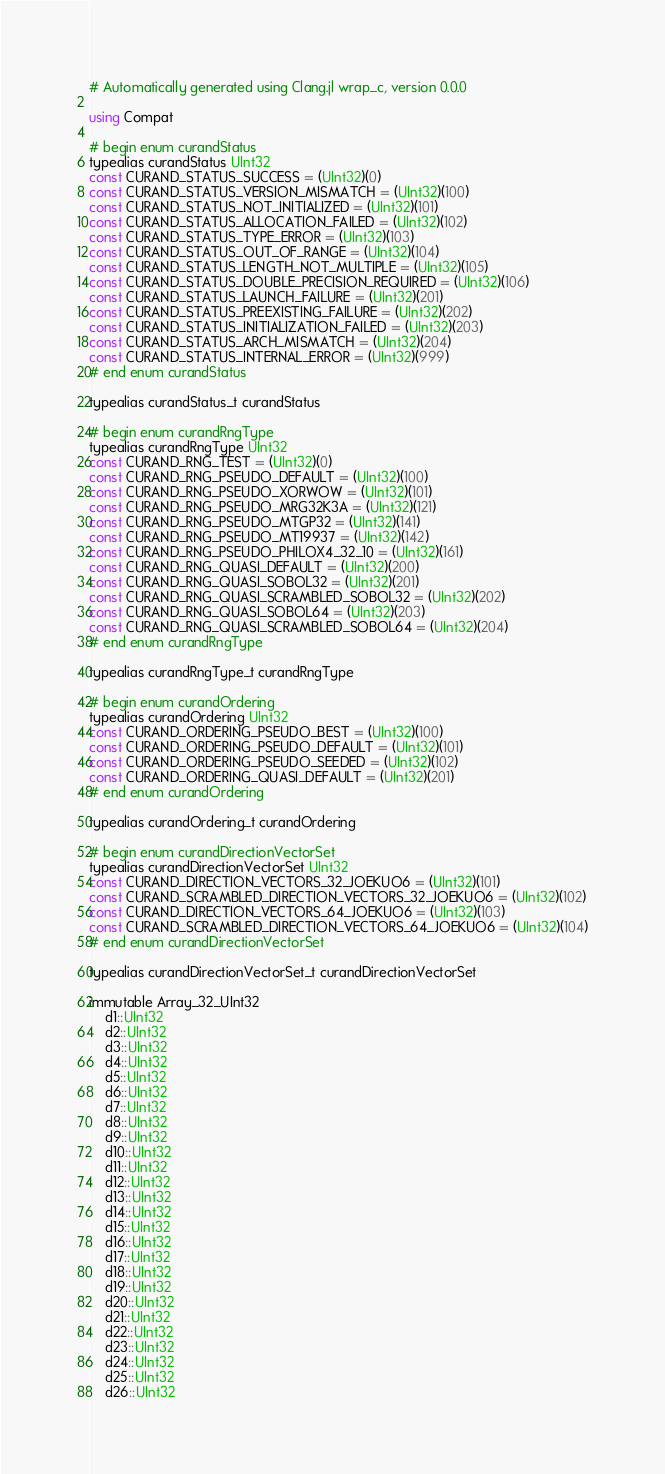Convert code to text. <code><loc_0><loc_0><loc_500><loc_500><_Julia_># Automatically generated using Clang.jl wrap_c, version 0.0.0

using Compat

# begin enum curandStatus
typealias curandStatus UInt32
const CURAND_STATUS_SUCCESS = (UInt32)(0)
const CURAND_STATUS_VERSION_MISMATCH = (UInt32)(100)
const CURAND_STATUS_NOT_INITIALIZED = (UInt32)(101)
const CURAND_STATUS_ALLOCATION_FAILED = (UInt32)(102)
const CURAND_STATUS_TYPE_ERROR = (UInt32)(103)
const CURAND_STATUS_OUT_OF_RANGE = (UInt32)(104)
const CURAND_STATUS_LENGTH_NOT_MULTIPLE = (UInt32)(105)
const CURAND_STATUS_DOUBLE_PRECISION_REQUIRED = (UInt32)(106)
const CURAND_STATUS_LAUNCH_FAILURE = (UInt32)(201)
const CURAND_STATUS_PREEXISTING_FAILURE = (UInt32)(202)
const CURAND_STATUS_INITIALIZATION_FAILED = (UInt32)(203)
const CURAND_STATUS_ARCH_MISMATCH = (UInt32)(204)
const CURAND_STATUS_INTERNAL_ERROR = (UInt32)(999)
# end enum curandStatus

typealias curandStatus_t curandStatus

# begin enum curandRngType
typealias curandRngType UInt32
const CURAND_RNG_TEST = (UInt32)(0)
const CURAND_RNG_PSEUDO_DEFAULT = (UInt32)(100)
const CURAND_RNG_PSEUDO_XORWOW = (UInt32)(101)
const CURAND_RNG_PSEUDO_MRG32K3A = (UInt32)(121)
const CURAND_RNG_PSEUDO_MTGP32 = (UInt32)(141)
const CURAND_RNG_PSEUDO_MT19937 = (UInt32)(142)
const CURAND_RNG_PSEUDO_PHILOX4_32_10 = (UInt32)(161)
const CURAND_RNG_QUASI_DEFAULT = (UInt32)(200)
const CURAND_RNG_QUASI_SOBOL32 = (UInt32)(201)
const CURAND_RNG_QUASI_SCRAMBLED_SOBOL32 = (UInt32)(202)
const CURAND_RNG_QUASI_SOBOL64 = (UInt32)(203)
const CURAND_RNG_QUASI_SCRAMBLED_SOBOL64 = (UInt32)(204)
# end enum curandRngType

typealias curandRngType_t curandRngType

# begin enum curandOrdering
typealias curandOrdering UInt32
const CURAND_ORDERING_PSEUDO_BEST = (UInt32)(100)
const CURAND_ORDERING_PSEUDO_DEFAULT = (UInt32)(101)
const CURAND_ORDERING_PSEUDO_SEEDED = (UInt32)(102)
const CURAND_ORDERING_QUASI_DEFAULT = (UInt32)(201)
# end enum curandOrdering

typealias curandOrdering_t curandOrdering

# begin enum curandDirectionVectorSet
typealias curandDirectionVectorSet UInt32
const CURAND_DIRECTION_VECTORS_32_JOEKUO6 = (UInt32)(101)
const CURAND_SCRAMBLED_DIRECTION_VECTORS_32_JOEKUO6 = (UInt32)(102)
const CURAND_DIRECTION_VECTORS_64_JOEKUO6 = (UInt32)(103)
const CURAND_SCRAMBLED_DIRECTION_VECTORS_64_JOEKUO6 = (UInt32)(104)
# end enum curandDirectionVectorSet

typealias curandDirectionVectorSet_t curandDirectionVectorSet

immutable Array_32_UInt32
    d1::UInt32
    d2::UInt32
    d3::UInt32
    d4::UInt32
    d5::UInt32
    d6::UInt32
    d7::UInt32
    d8::UInt32
    d9::UInt32
    d10::UInt32
    d11::UInt32
    d12::UInt32
    d13::UInt32
    d14::UInt32
    d15::UInt32
    d16::UInt32
    d17::UInt32
    d18::UInt32
    d19::UInt32
    d20::UInt32
    d21::UInt32
    d22::UInt32
    d23::UInt32
    d24::UInt32
    d25::UInt32
    d26::UInt32</code> 